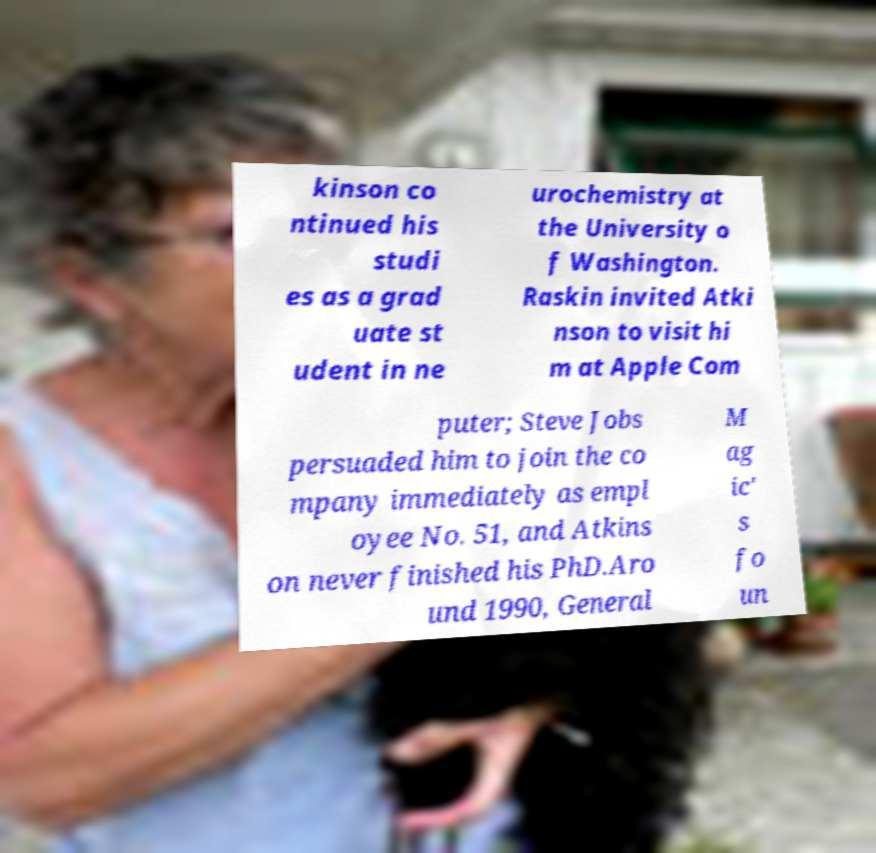Please read and relay the text visible in this image. What does it say? kinson co ntinued his studi es as a grad uate st udent in ne urochemistry at the University o f Washington. Raskin invited Atki nson to visit hi m at Apple Com puter; Steve Jobs persuaded him to join the co mpany immediately as empl oyee No. 51, and Atkins on never finished his PhD.Aro und 1990, General M ag ic' s fo un 